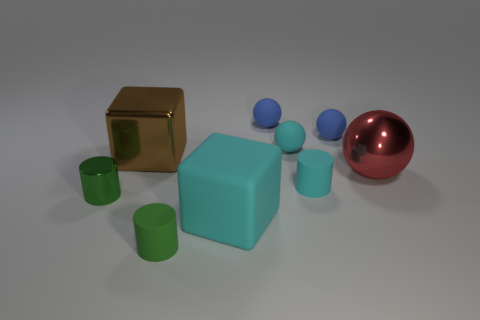Subtract 1 spheres. How many spheres are left? 3 Add 1 matte objects. How many objects exist? 10 Subtract all spheres. How many objects are left? 5 Add 2 small cylinders. How many small cylinders are left? 5 Add 3 cyan matte things. How many cyan matte things exist? 6 Subtract 1 cyan cylinders. How many objects are left? 8 Subtract all cyan rubber things. Subtract all tiny blue rubber spheres. How many objects are left? 4 